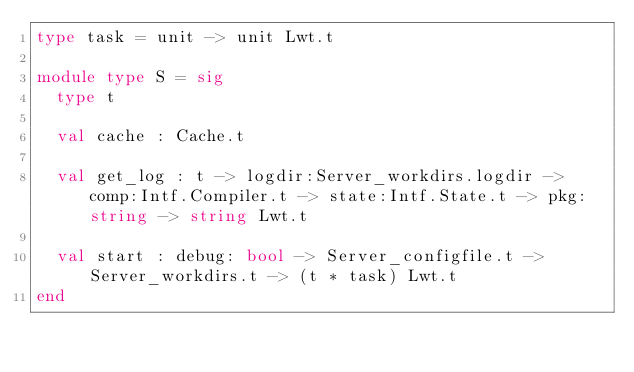<code> <loc_0><loc_0><loc_500><loc_500><_OCaml_>type task = unit -> unit Lwt.t

module type S = sig
  type t

  val cache : Cache.t

  val get_log : t -> logdir:Server_workdirs.logdir -> comp:Intf.Compiler.t -> state:Intf.State.t -> pkg:string -> string Lwt.t

  val start : debug: bool -> Server_configfile.t -> Server_workdirs.t -> (t * task) Lwt.t
end
</code> 